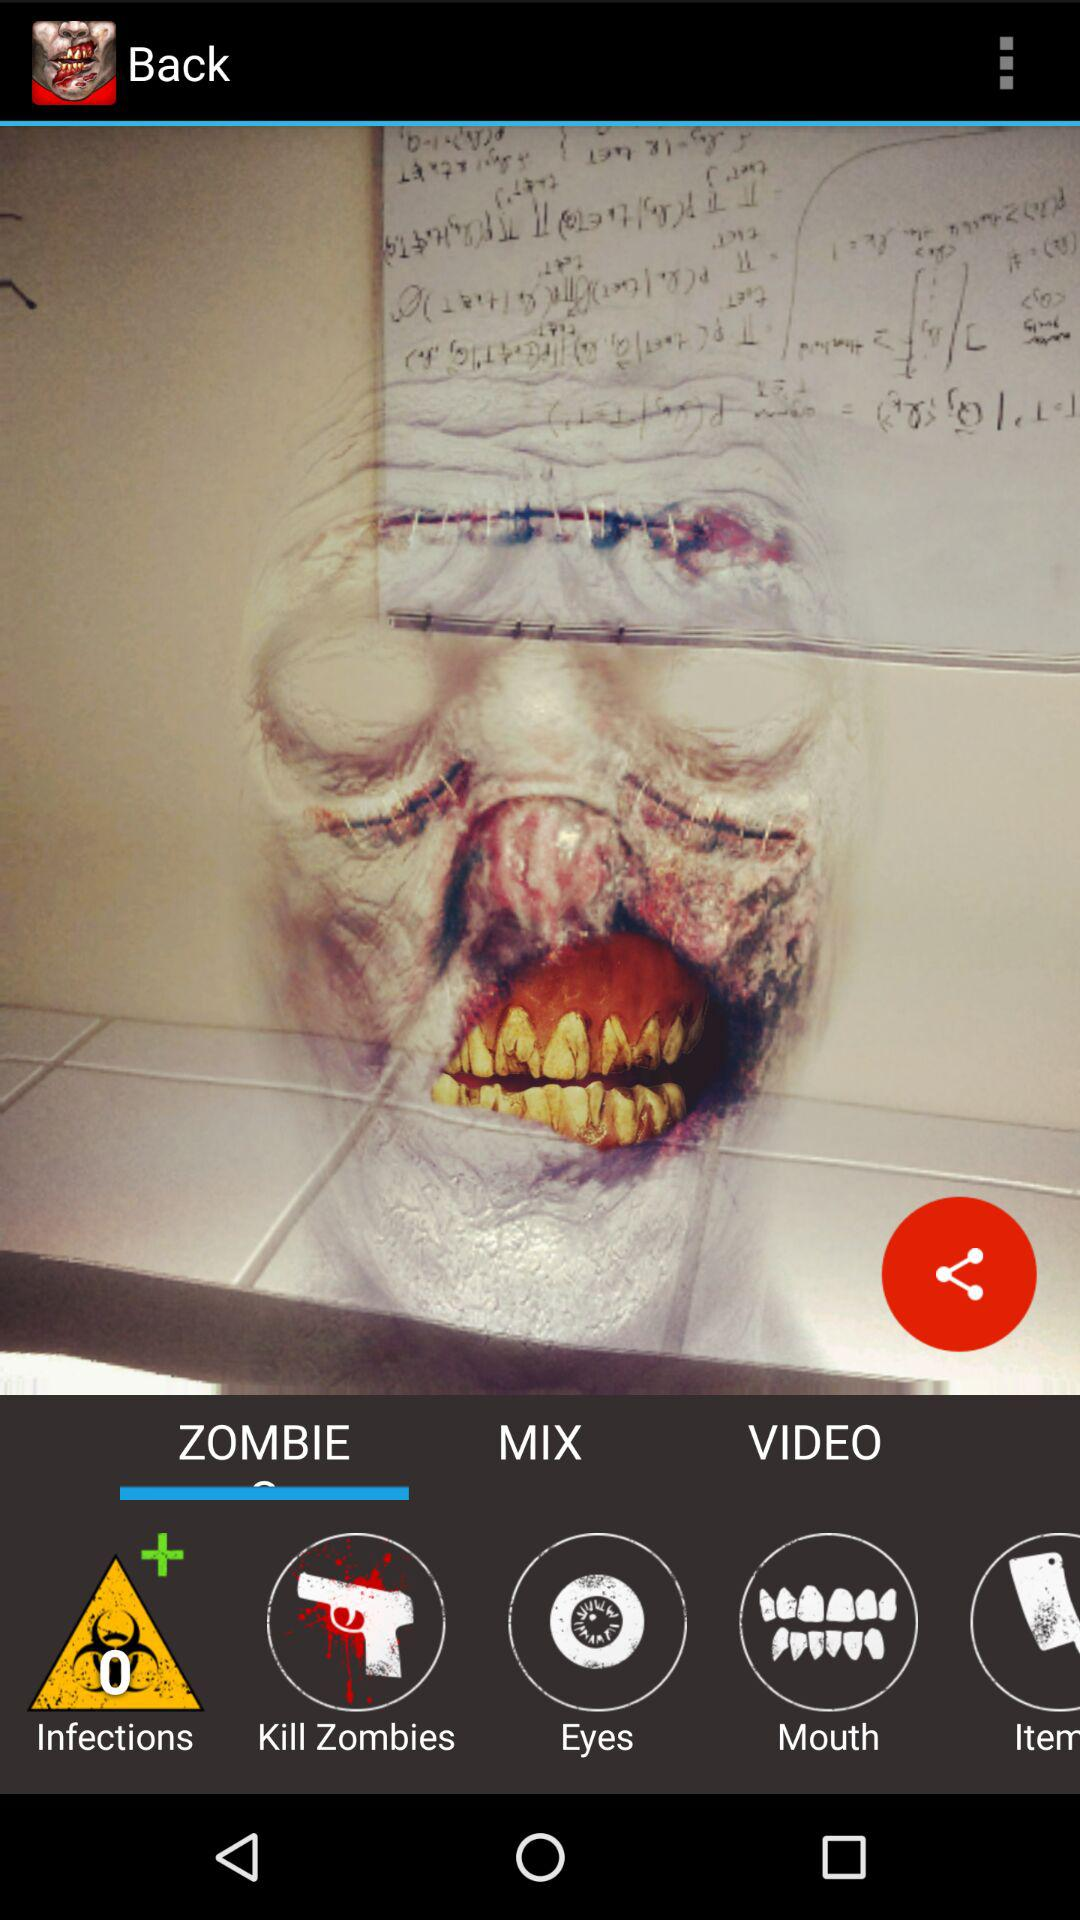Which tab is selected?
When the provided information is insufficient, respond with <no answer>. <no answer> 